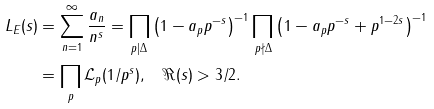Convert formula to latex. <formula><loc_0><loc_0><loc_500><loc_500>L _ { E } ( s ) & = \sum _ { n = 1 } ^ { \infty } \frac { a _ { n } } { n ^ { s } } = \prod _ { p | \Delta } \left ( 1 - a _ { p } p ^ { - s } \right ) ^ { - 1 } \prod _ { p \nmid \Delta } \left ( 1 - a _ { p } p ^ { - s } + p ^ { 1 - 2 s } \right ) ^ { - 1 } \\ & = \prod _ { p } { \mathcal { L } } _ { p } ( 1 / p ^ { s } ) , \quad \Re ( s ) > 3 / 2 .</formula> 